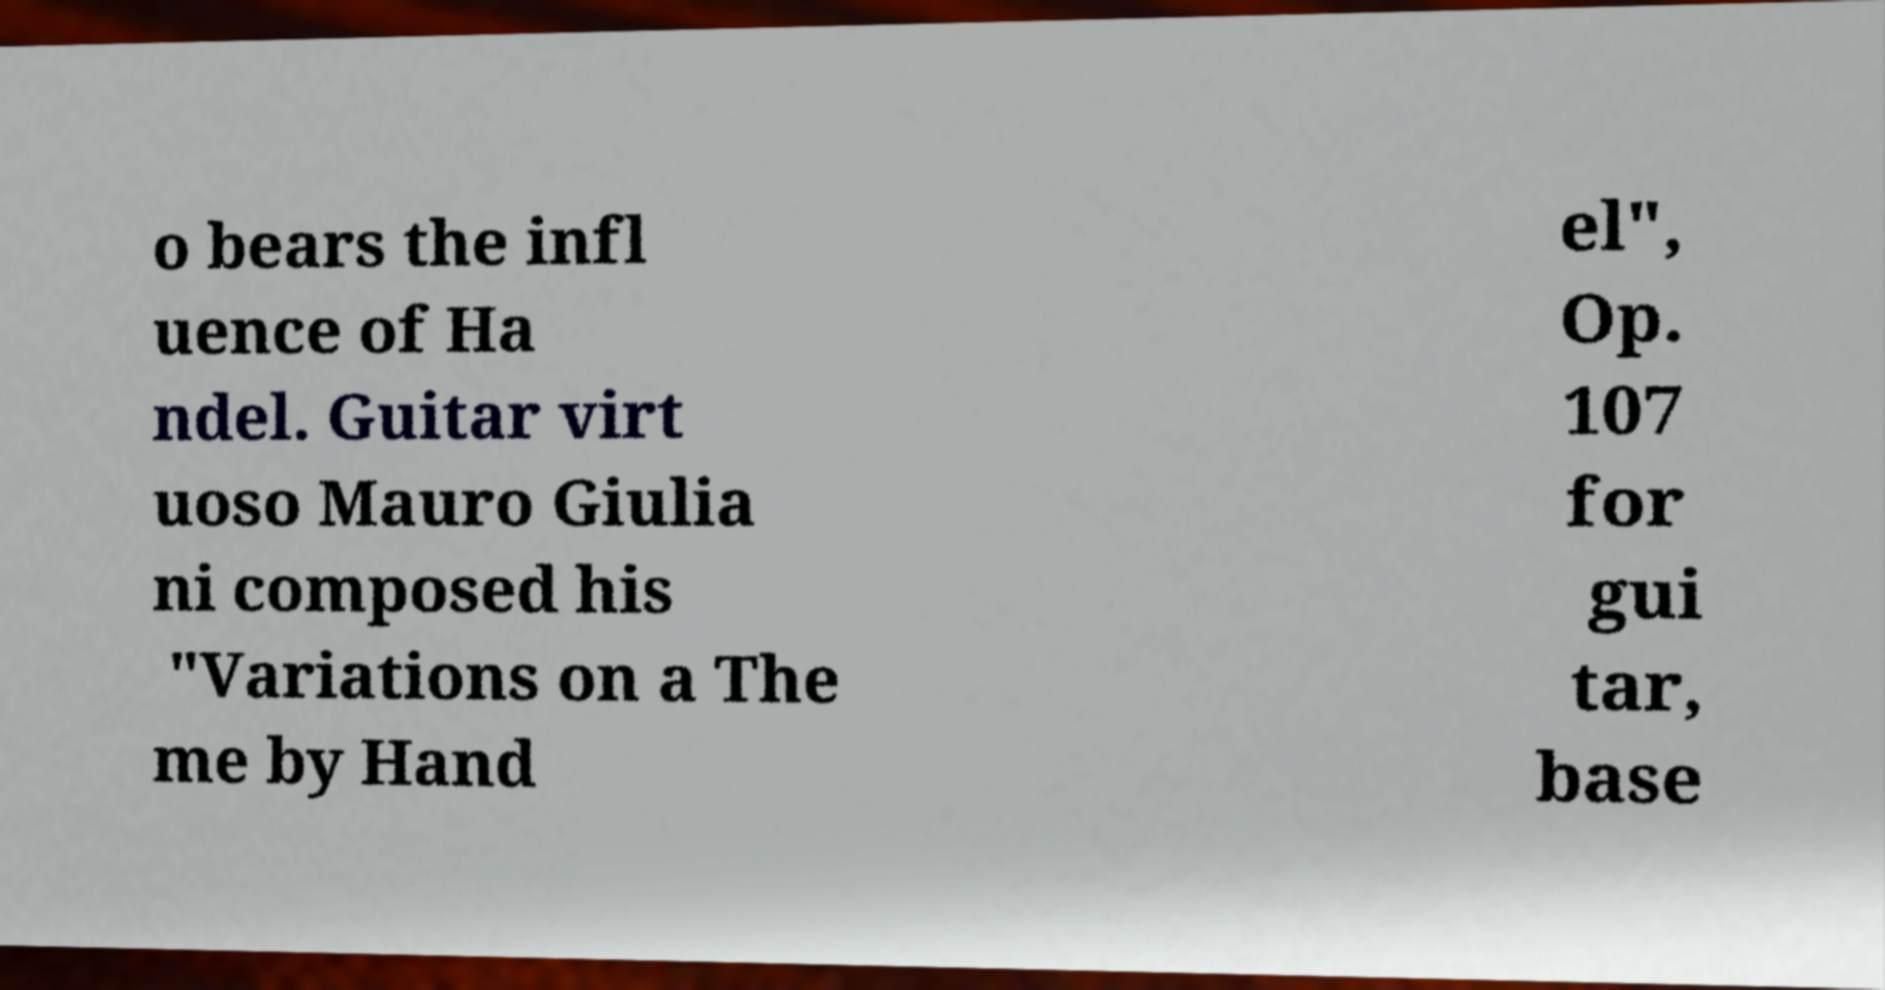Could you assist in decoding the text presented in this image and type it out clearly? o bears the infl uence of Ha ndel. Guitar virt uoso Mauro Giulia ni composed his "Variations on a The me by Hand el", Op. 107 for gui tar, base 